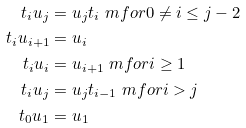<formula> <loc_0><loc_0><loc_500><loc_500>t _ { i } u _ { j } & = u _ { j } t _ { i } \ m f o r 0 \neq i \leq j - 2 \\ t _ { i } u _ { i + 1 } & = u _ { i } \\ t _ { i } u _ { i } & = u _ { i + 1 } \ m f o r i \geq 1 \\ t _ { i } u _ { j } & = u _ { j } t _ { i - 1 } \ m f o r i > j \\ t _ { 0 } u _ { 1 } & = u _ { 1 }</formula> 